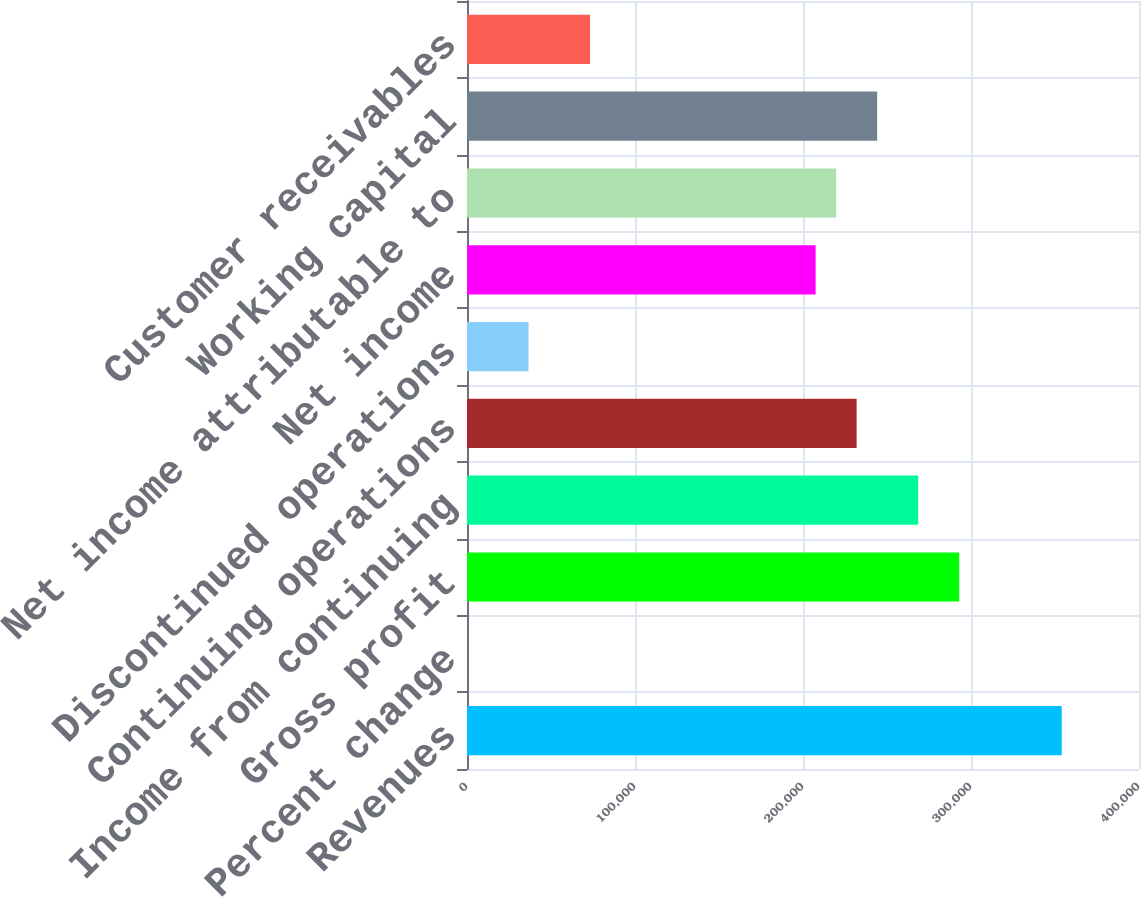Convert chart to OTSL. <chart><loc_0><loc_0><loc_500><loc_500><bar_chart><fcel>Revenues<fcel>Percent change<fcel>Gross profit<fcel>Income from continuing<fcel>Continuing operations<fcel>Discontinued operations<fcel>Net income<fcel>Net income attributable to<fcel>Working capital<fcel>Customer receivables<nl><fcel>354000<fcel>0.2<fcel>292965<fcel>268552<fcel>231931<fcel>36620.8<fcel>207517<fcel>219724<fcel>244138<fcel>73241.5<nl></chart> 